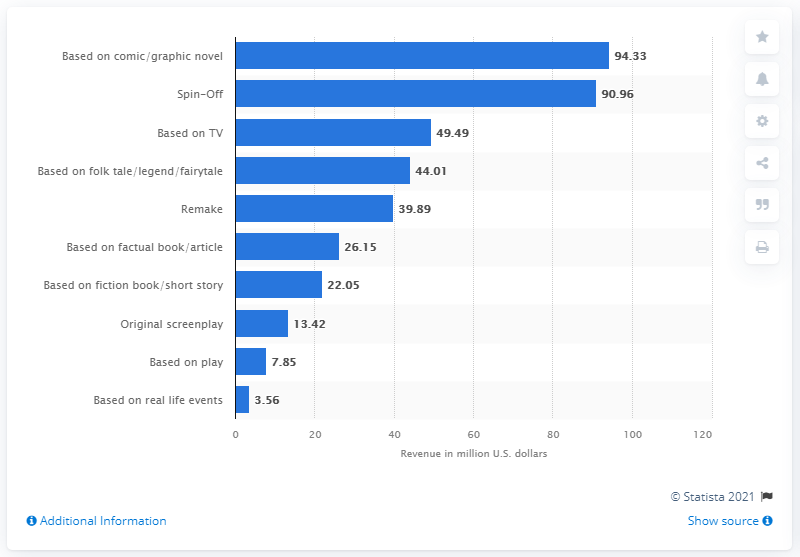List a handful of essential elements in this visual. The average revenue from movies based on comics and graphic novels between 1995 and 2021 was $94.33. 